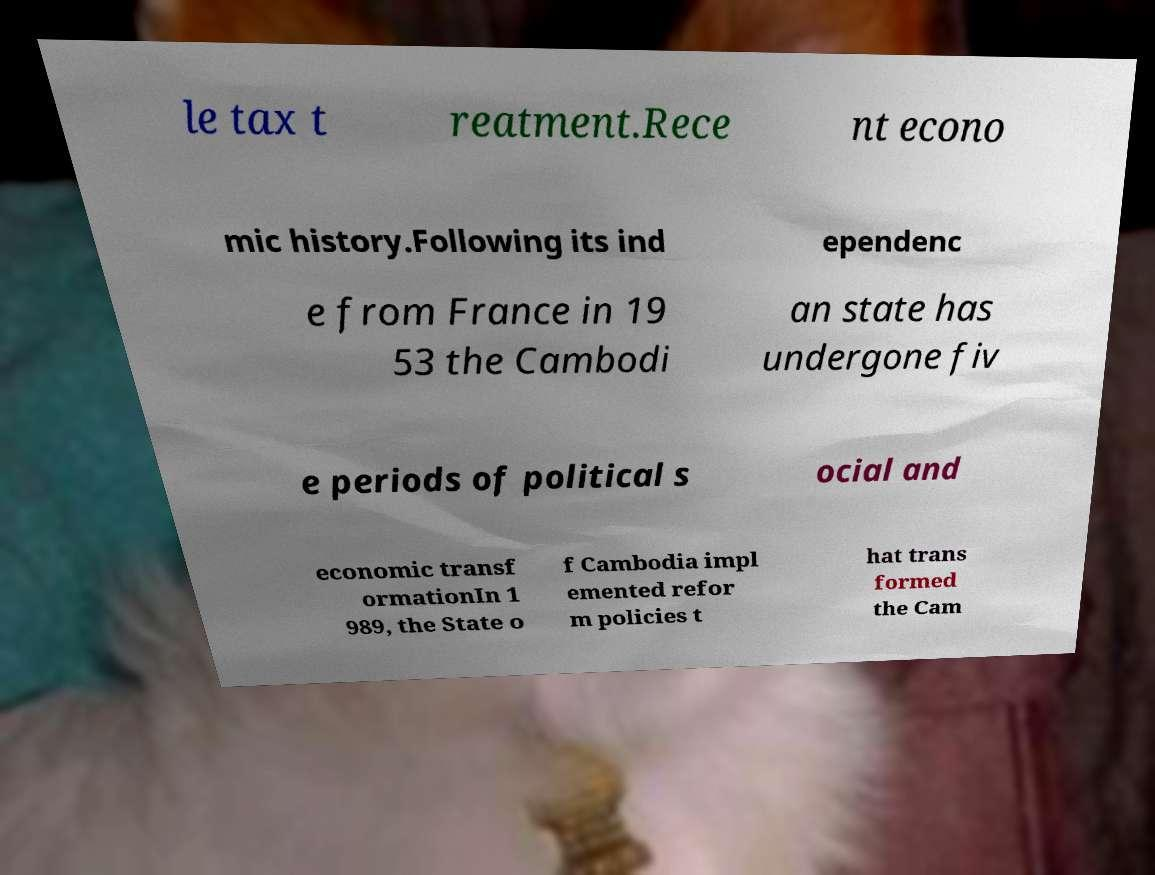For documentation purposes, I need the text within this image transcribed. Could you provide that? le tax t reatment.Rece nt econo mic history.Following its ind ependenc e from France in 19 53 the Cambodi an state has undergone fiv e periods of political s ocial and economic transf ormationIn 1 989, the State o f Cambodia impl emented refor m policies t hat trans formed the Cam 